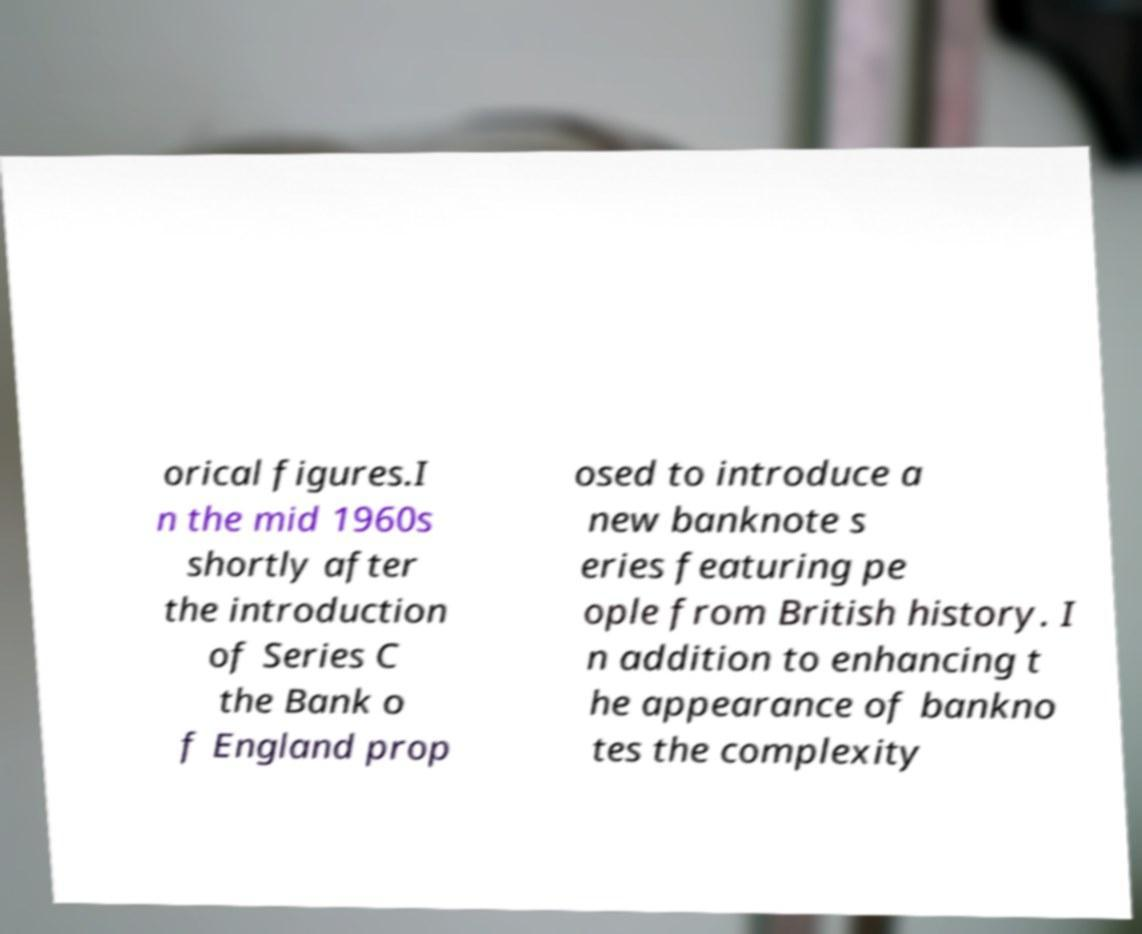For documentation purposes, I need the text within this image transcribed. Could you provide that? orical figures.I n the mid 1960s shortly after the introduction of Series C the Bank o f England prop osed to introduce a new banknote s eries featuring pe ople from British history. I n addition to enhancing t he appearance of bankno tes the complexity 